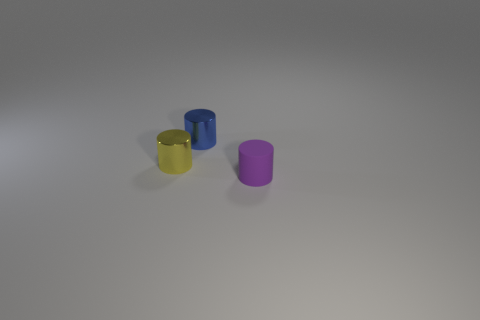Add 1 tiny blue cylinders. How many objects exist? 4 Add 1 tiny blue metal things. How many tiny blue metal things are left? 2 Add 1 shiny cylinders. How many shiny cylinders exist? 3 Subtract 0 red blocks. How many objects are left? 3 Subtract all green rubber balls. Subtract all tiny yellow metal things. How many objects are left? 2 